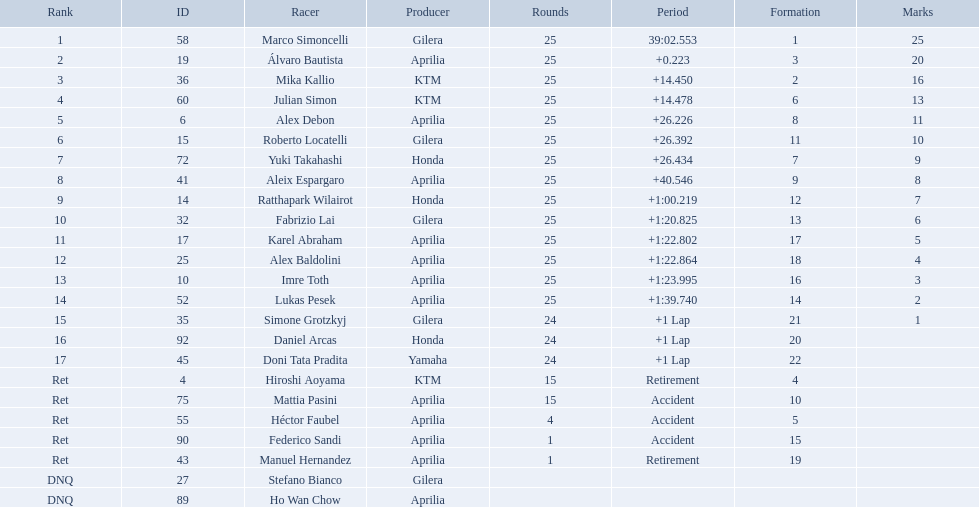Who were all of the riders? Marco Simoncelli, Álvaro Bautista, Mika Kallio, Julian Simon, Alex Debon, Roberto Locatelli, Yuki Takahashi, Aleix Espargaro, Ratthapark Wilairot, Fabrizio Lai, Karel Abraham, Alex Baldolini, Imre Toth, Lukas Pesek, Simone Grotzkyj, Daniel Arcas, Doni Tata Pradita, Hiroshi Aoyama, Mattia Pasini, Héctor Faubel, Federico Sandi, Manuel Hernandez, Stefano Bianco, Ho Wan Chow. How many laps did they complete? 25, 25, 25, 25, 25, 25, 25, 25, 25, 25, 25, 25, 25, 25, 24, 24, 24, 15, 15, 4, 1, 1, , . Between marco simoncelli and hiroshi aoyama, who had more laps? Marco Simoncelli. What player number is marked #1 for the australian motorcycle grand prix? 58. Who is the rider that represents the #58 in the australian motorcycle grand prix? Marco Simoncelli. Who are all the riders? Marco Simoncelli, Álvaro Bautista, Mika Kallio, Julian Simon, Alex Debon, Roberto Locatelli, Yuki Takahashi, Aleix Espargaro, Ratthapark Wilairot, Fabrizio Lai, Karel Abraham, Alex Baldolini, Imre Toth, Lukas Pesek, Simone Grotzkyj, Daniel Arcas, Doni Tata Pradita, Hiroshi Aoyama, Mattia Pasini, Héctor Faubel, Federico Sandi, Manuel Hernandez, Stefano Bianco, Ho Wan Chow. Which held rank 1? Marco Simoncelli. 